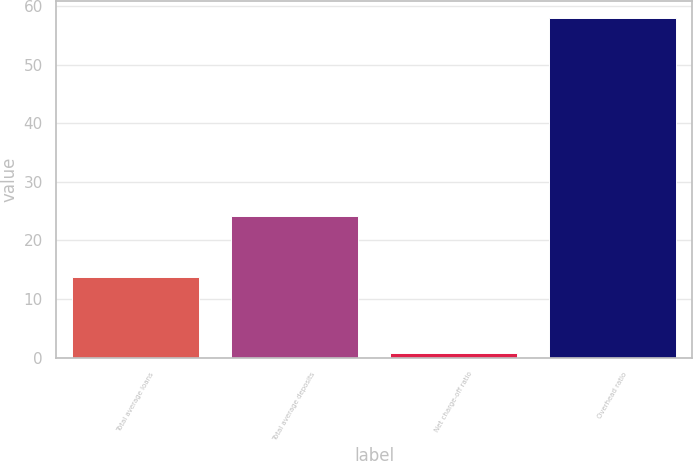Convert chart to OTSL. <chart><loc_0><loc_0><loc_500><loc_500><bar_chart><fcel>Total average loans<fcel>Total average deposits<fcel>Net charge-off ratio<fcel>Overhead ratio<nl><fcel>13.7<fcel>24.1<fcel>0.78<fcel>58<nl></chart> 